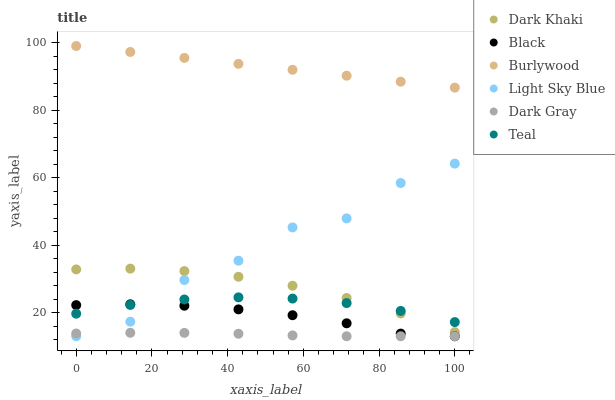Does Dark Gray have the minimum area under the curve?
Answer yes or no. Yes. Does Burlywood have the maximum area under the curve?
Answer yes or no. Yes. Does Dark Khaki have the minimum area under the curve?
Answer yes or no. No. Does Dark Khaki have the maximum area under the curve?
Answer yes or no. No. Is Burlywood the smoothest?
Answer yes or no. Yes. Is Light Sky Blue the roughest?
Answer yes or no. Yes. Is Dark Khaki the smoothest?
Answer yes or no. No. Is Dark Khaki the roughest?
Answer yes or no. No. Does Dark Gray have the lowest value?
Answer yes or no. Yes. Does Dark Khaki have the lowest value?
Answer yes or no. No. Does Burlywood have the highest value?
Answer yes or no. Yes. Does Dark Khaki have the highest value?
Answer yes or no. No. Is Dark Gray less than Teal?
Answer yes or no. Yes. Is Dark Khaki greater than Dark Gray?
Answer yes or no. Yes. Does Dark Khaki intersect Teal?
Answer yes or no. Yes. Is Dark Khaki less than Teal?
Answer yes or no. No. Is Dark Khaki greater than Teal?
Answer yes or no. No. Does Dark Gray intersect Teal?
Answer yes or no. No. 